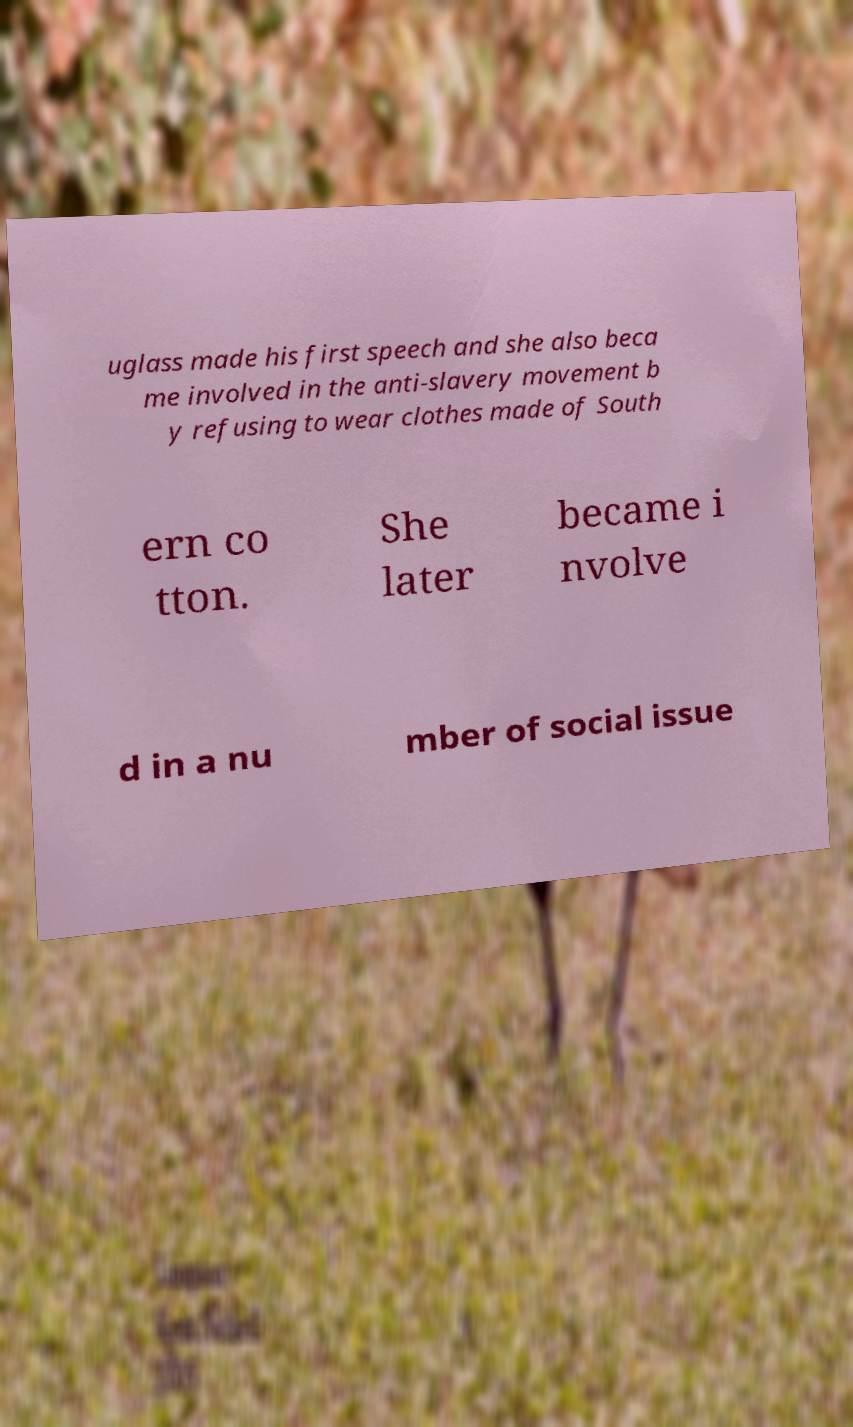Could you assist in decoding the text presented in this image and type it out clearly? uglass made his first speech and she also beca me involved in the anti-slavery movement b y refusing to wear clothes made of South ern co tton. She later became i nvolve d in a nu mber of social issue 